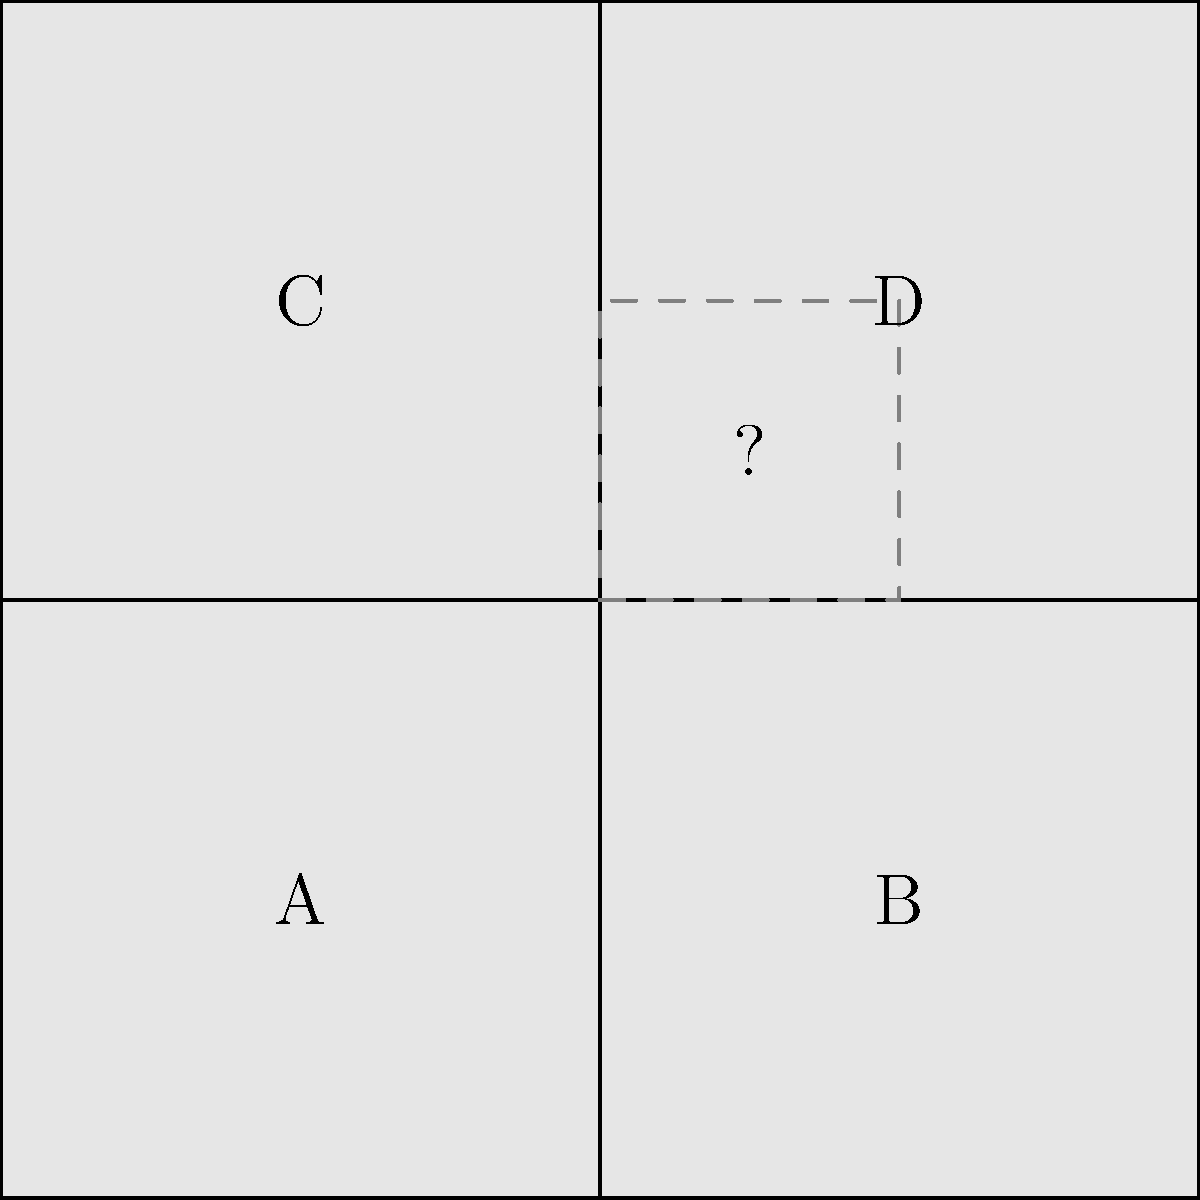In the puzzle shown above, pieces A, B, C, and D are present, but there is a missing piece in the center. Which shape would best complete the puzzle, symbolizing the process of filling the void left by loss? To solve this puzzle and understand its symbolism, let's follow these steps:

1. Observe the existing pieces: The puzzle consists of four square pieces (A, B, C, D) arranged in a 2x2 grid.

2. Identify the missing area: There is a square-shaped void in the center where the four pieces meet.

3. Analyze the symbolism: The missing piece represents the void left by loss, in this case, the loss of parents.

4. Consider the healing process: Completing the puzzle symbolizes the journey of healing and coming to terms with grief.

5. Determine the shape needed: To complete the puzzle, we need a square piece that fits in the center, connecting all four existing pieces.

6. Reflect on the meaning: By filling the void with a square piece, we symbolize the process of acknowledging the loss and finding a way to integrate it into one's life story.

7. Understand the continuity: The completed puzzle represents a whole picture, showing that life can continue and find new meaning even after significant loss.

Therefore, the shape that would best complete the puzzle and symbolize the process of healing from loss is a square piece that fits perfectly in the center.
Answer: A square 